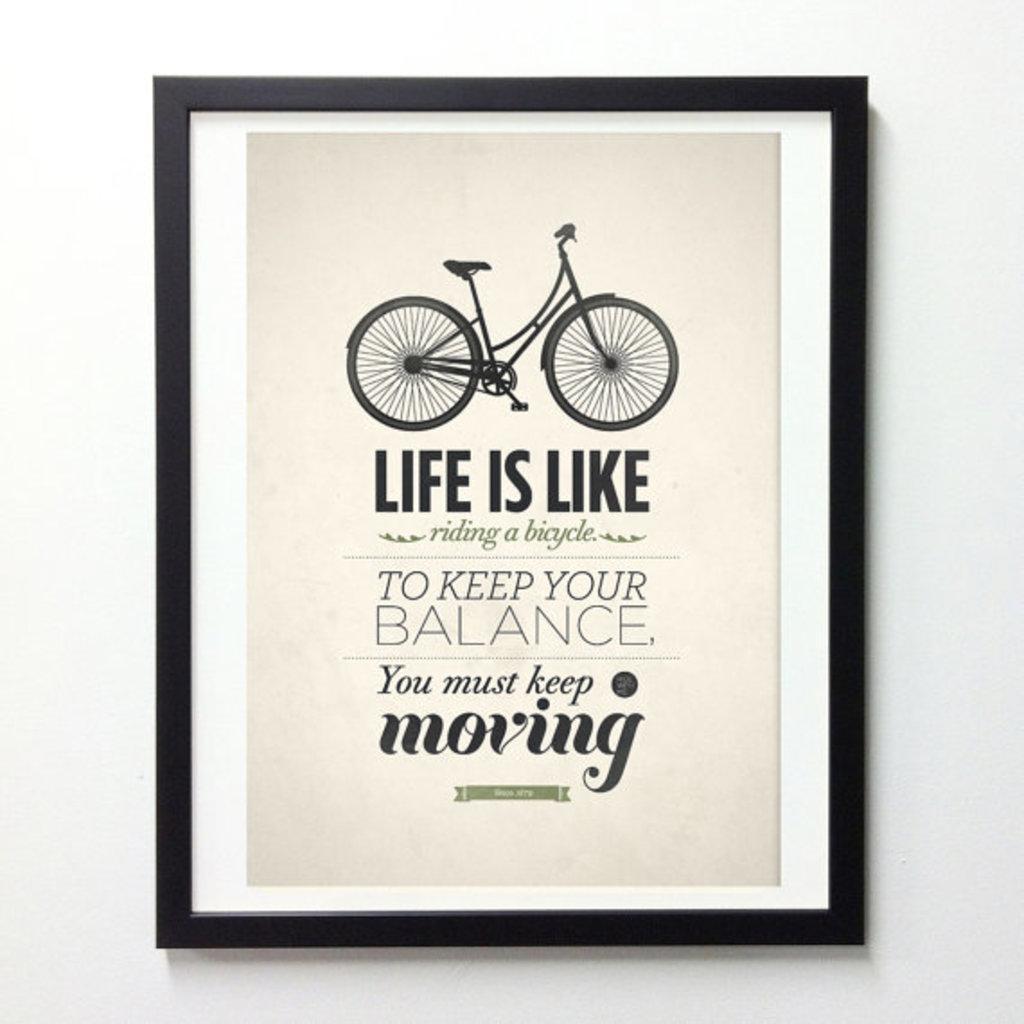Could you give a brief overview of what you see in this image? In this image, we can see a photo on the wall, in that photo, we can see a picture of a bicycle and there is some text on the photo. 